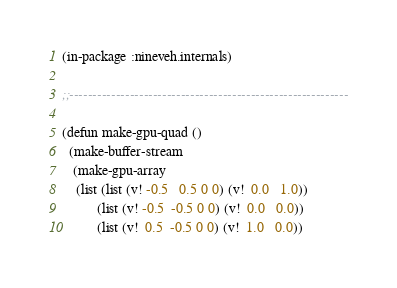<code> <loc_0><loc_0><loc_500><loc_500><_Lisp_>(in-package :nineveh.internals)

;;------------------------------------------------------------

(defun make-gpu-quad ()
  (make-buffer-stream
   (make-gpu-array
    (list (list (v! -0.5   0.5 0 0) (v!  0.0   1.0))
          (list (v! -0.5  -0.5 0 0) (v!  0.0   0.0))
          (list (v!  0.5  -0.5 0 0) (v!  1.0   0.0))</code> 